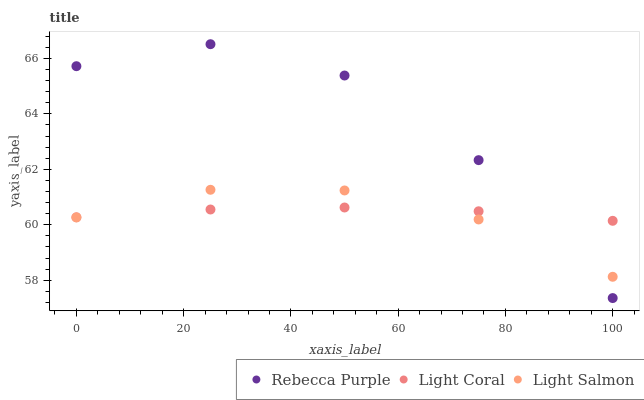Does Light Coral have the minimum area under the curve?
Answer yes or no. Yes. Does Rebecca Purple have the maximum area under the curve?
Answer yes or no. Yes. Does Light Salmon have the minimum area under the curve?
Answer yes or no. No. Does Light Salmon have the maximum area under the curve?
Answer yes or no. No. Is Light Coral the smoothest?
Answer yes or no. Yes. Is Rebecca Purple the roughest?
Answer yes or no. Yes. Is Light Salmon the smoothest?
Answer yes or no. No. Is Light Salmon the roughest?
Answer yes or no. No. Does Rebecca Purple have the lowest value?
Answer yes or no. Yes. Does Light Salmon have the lowest value?
Answer yes or no. No. Does Rebecca Purple have the highest value?
Answer yes or no. Yes. Does Light Salmon have the highest value?
Answer yes or no. No. Does Light Coral intersect Rebecca Purple?
Answer yes or no. Yes. Is Light Coral less than Rebecca Purple?
Answer yes or no. No. Is Light Coral greater than Rebecca Purple?
Answer yes or no. No. 